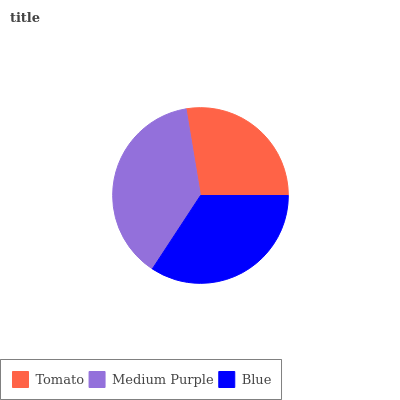Is Tomato the minimum?
Answer yes or no. Yes. Is Medium Purple the maximum?
Answer yes or no. Yes. Is Blue the minimum?
Answer yes or no. No. Is Blue the maximum?
Answer yes or no. No. Is Medium Purple greater than Blue?
Answer yes or no. Yes. Is Blue less than Medium Purple?
Answer yes or no. Yes. Is Blue greater than Medium Purple?
Answer yes or no. No. Is Medium Purple less than Blue?
Answer yes or no. No. Is Blue the high median?
Answer yes or no. Yes. Is Blue the low median?
Answer yes or no. Yes. Is Tomato the high median?
Answer yes or no. No. Is Medium Purple the low median?
Answer yes or no. No. 